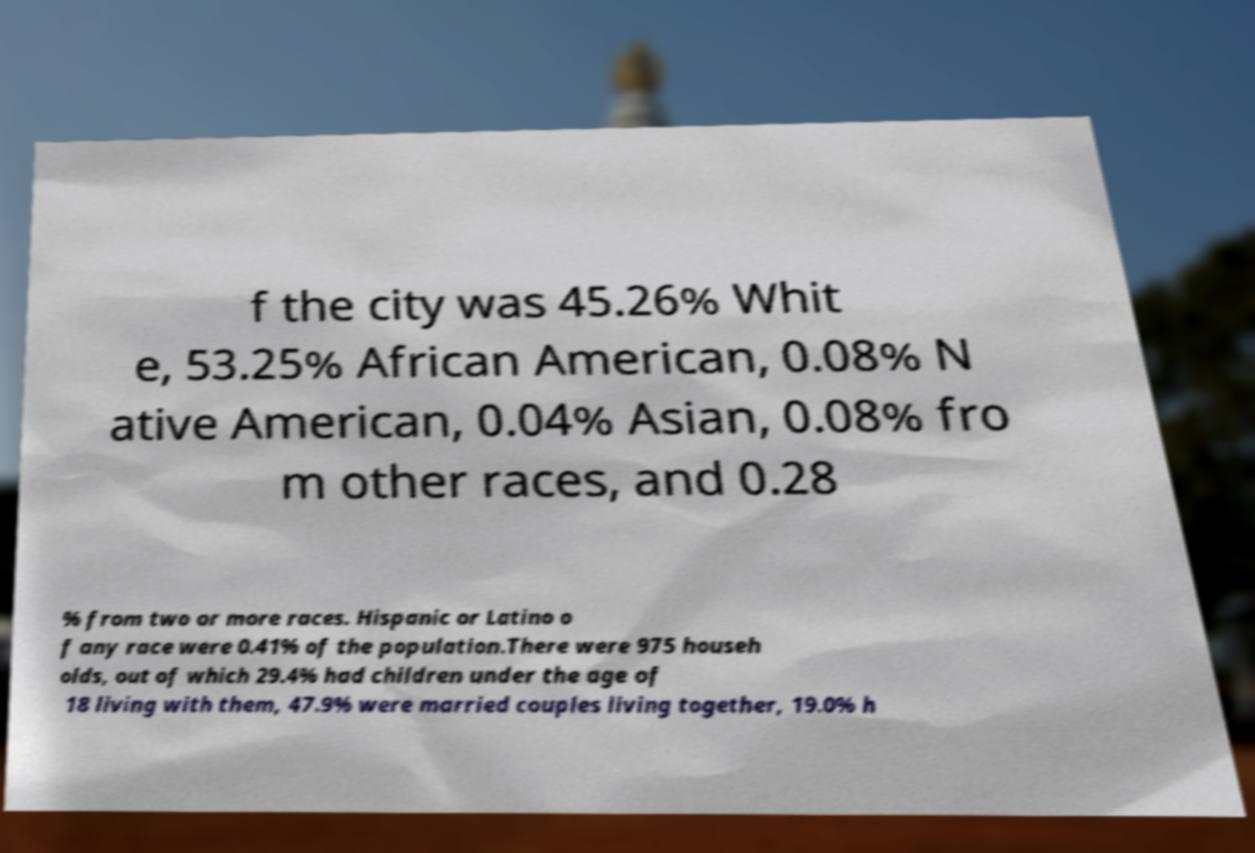Could you extract and type out the text from this image? f the city was 45.26% Whit e, 53.25% African American, 0.08% N ative American, 0.04% Asian, 0.08% fro m other races, and 0.28 % from two or more races. Hispanic or Latino o f any race were 0.41% of the population.There were 975 househ olds, out of which 29.4% had children under the age of 18 living with them, 47.9% were married couples living together, 19.0% h 